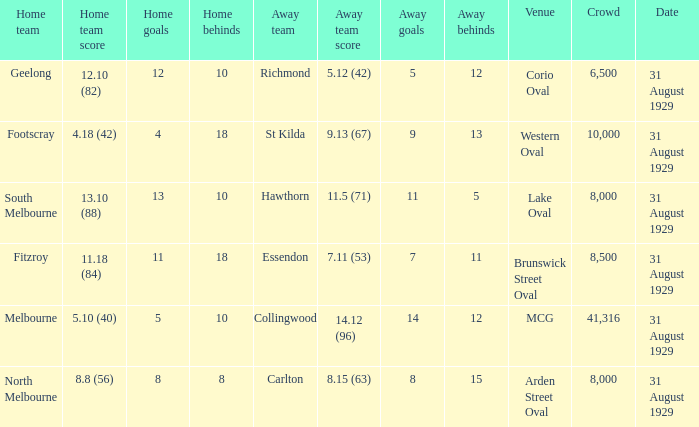What was the away team when the game was at corio oval? Richmond. 